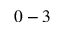Convert formula to latex. <formula><loc_0><loc_0><loc_500><loc_500>0 - 3</formula> 